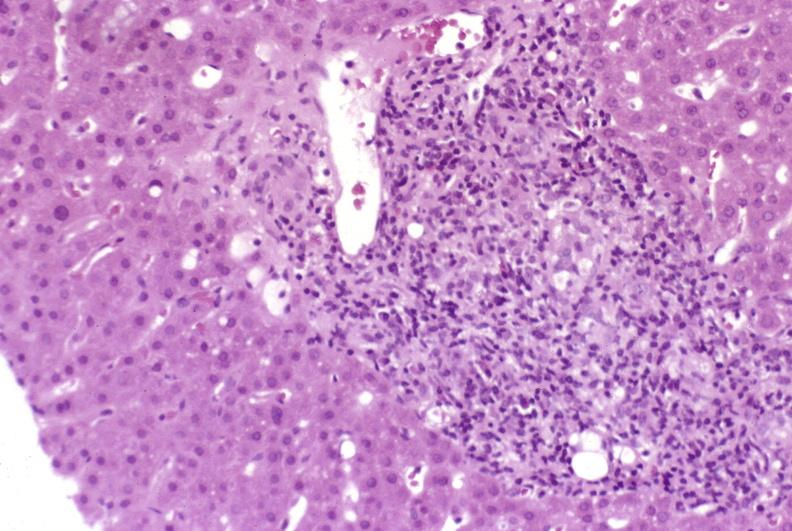s hepatobiliary present?
Answer the question using a single word or phrase. Yes 